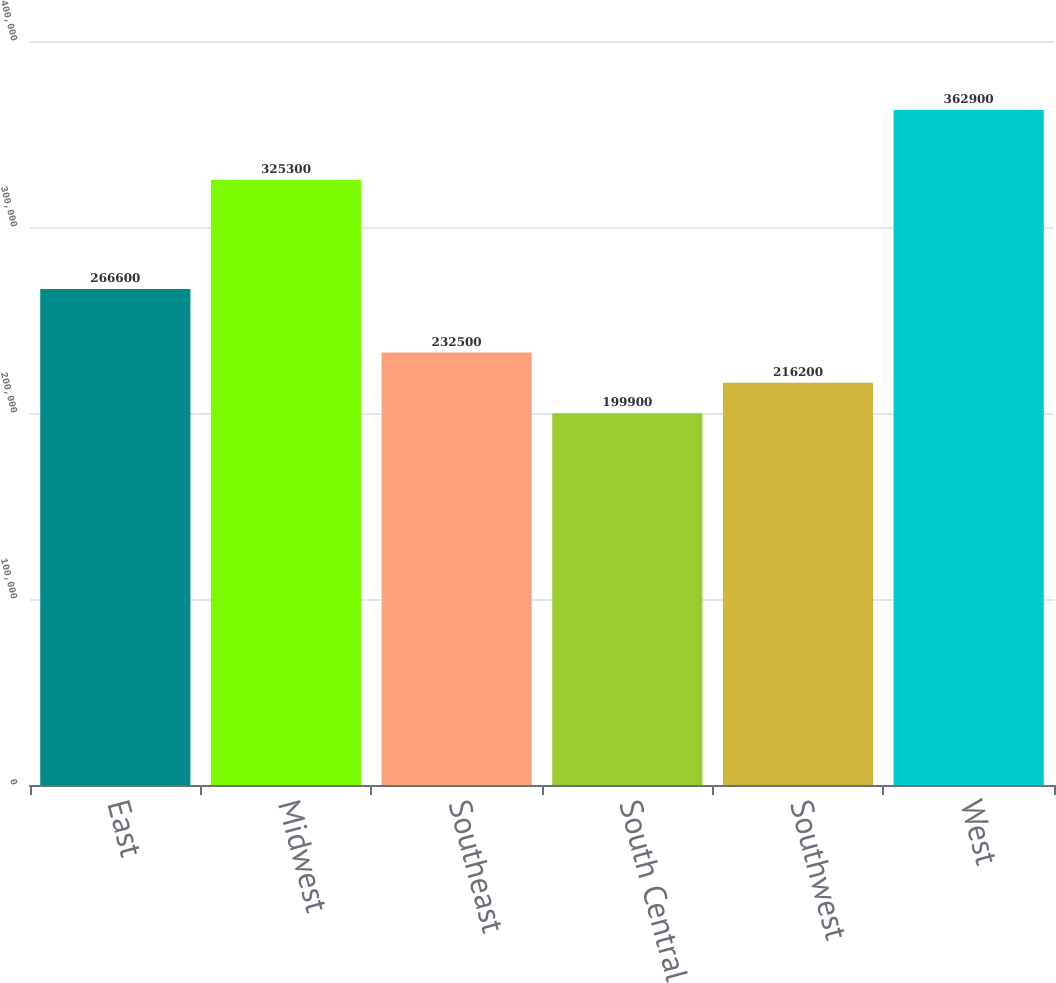Convert chart. <chart><loc_0><loc_0><loc_500><loc_500><bar_chart><fcel>East<fcel>Midwest<fcel>Southeast<fcel>South Central<fcel>Southwest<fcel>West<nl><fcel>266600<fcel>325300<fcel>232500<fcel>199900<fcel>216200<fcel>362900<nl></chart> 